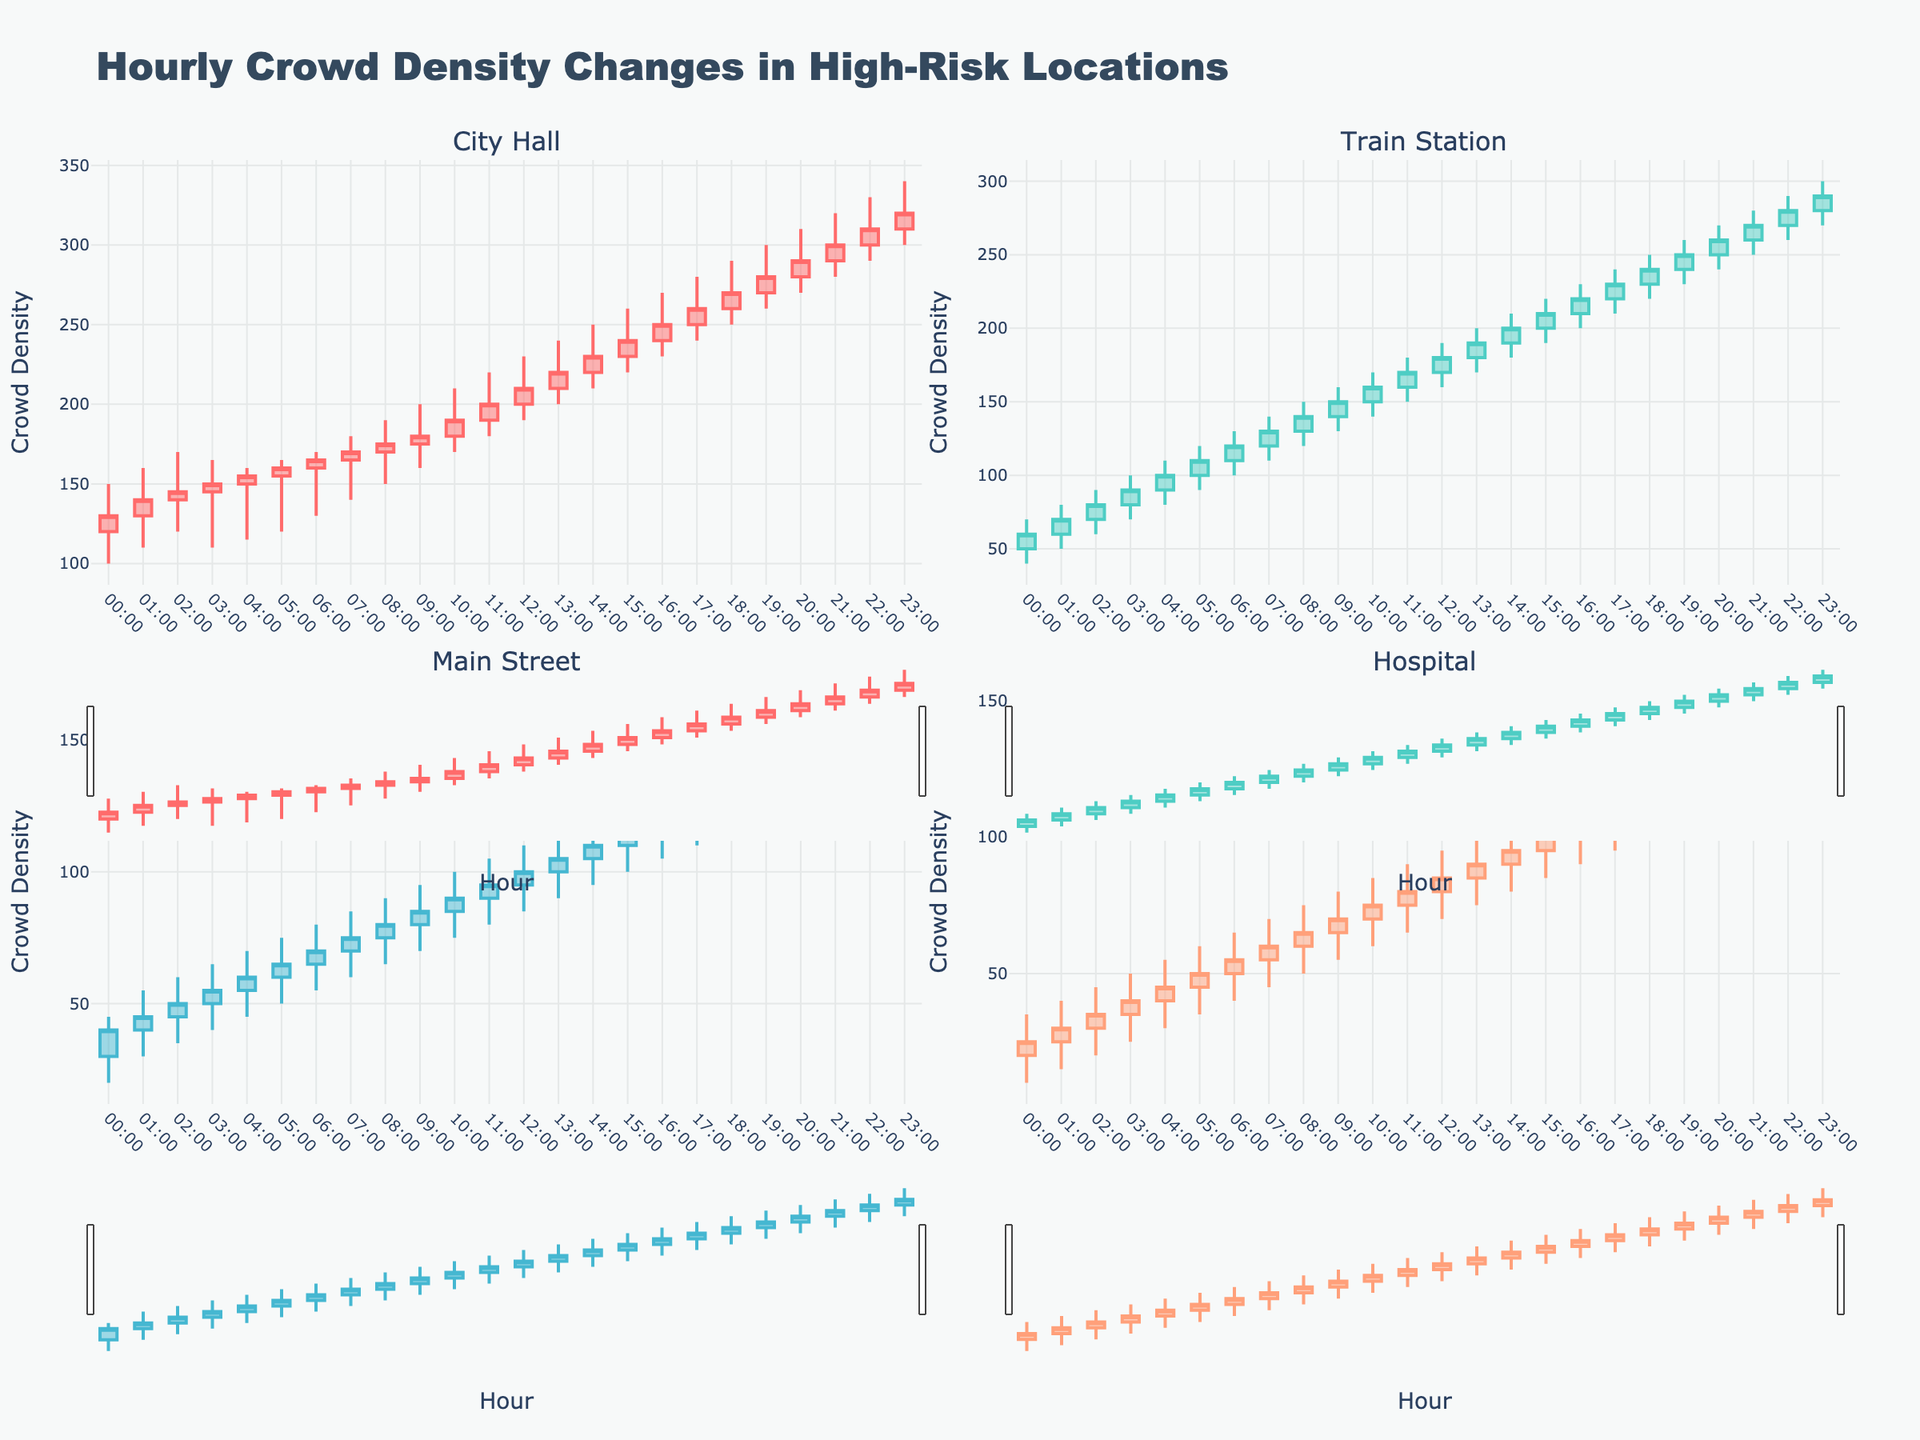What is the title of the figure? The title can be found at the top center of the figure in large, bold letters. It states the main subject of the figure and provides context.
Answer: Hourly Crowd Density Changes in High-Risk Locations What are the four high-risk locations represented in the figure? The subplot titles indicate the names of the locations being analyzed. Each subplot corresponds to one of the locations.
Answer: City Hall, Train Station, Main Street, Hospital Which hours show the highest crowd density at City Hall? For City Hall, check the candlestick plot for the hour with the highest 'High' value, which represents the peak crowd density for that hour.
Answer: 23:00 At which location and hour is the lowest crowd density recorded? Look for the lowest 'Low' value across all the subplots. This can be found by identifying the shortest candlestick shadows.
Answer: Hospital, 00:00 How does the crowd density at Train Station at 11:00 compare to that at Main Street at 11:00? Compare the 'Close' values for 11:00 at both the Train Station and Main Street subplots. This indicates the closing crowd density at that hour.
Answer: Higher at Train Station At what hour does the crowd density at Hospital first exceed 50? Check the candlestick plots for Hospital and identify the first hour where the 'Close' value exceeds 50.
Answer: 06:00 What is the average closing crowd density at City Hall between 12:00 and 15:00? Sum the 'Close' values for City Hall from 12:00 to 15:00 and divide by the number of hours (4). (210 + 220 + 230 + 240) / 4 = 225
Answer: 225 Which location shows the most consistent crowd density throughout the day? Look for the location with the least variance in the candlestick sizes, indicating little fluctuation in crowd density.
Answer: Hospital During which hour is the range of crowd density (High - Low) the largest for Main Street? For Main Street, calculate the difference between 'High' and 'Low' for each hour and identify the maximum range.
Answer: 22:00 What is the overall trend in crowd density at the Train Station from 00:00 to 23:00? Examine the direction of the candlesticks from 00:00 to 23:00 to determine if they are generally increasing, decreasing, or fluctuating.
Answer: Increasing 